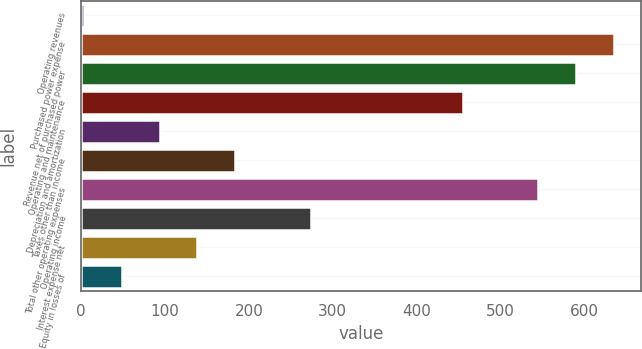Convert chart to OTSL. <chart><loc_0><loc_0><loc_500><loc_500><bar_chart><fcel>Operating revenues<fcel>Purchased power expense<fcel>Revenue net of purchased power<fcel>Operating and maintenance<fcel>Depreciation and amortization<fcel>Taxes other than income<fcel>Total other operating expenses<fcel>Operating income<fcel>Interest expense net<fcel>Equity in losses of<nl><fcel>3<fcel>635.8<fcel>590.6<fcel>455<fcel>93.4<fcel>183.8<fcel>545.4<fcel>274.2<fcel>138.6<fcel>48.2<nl></chart> 